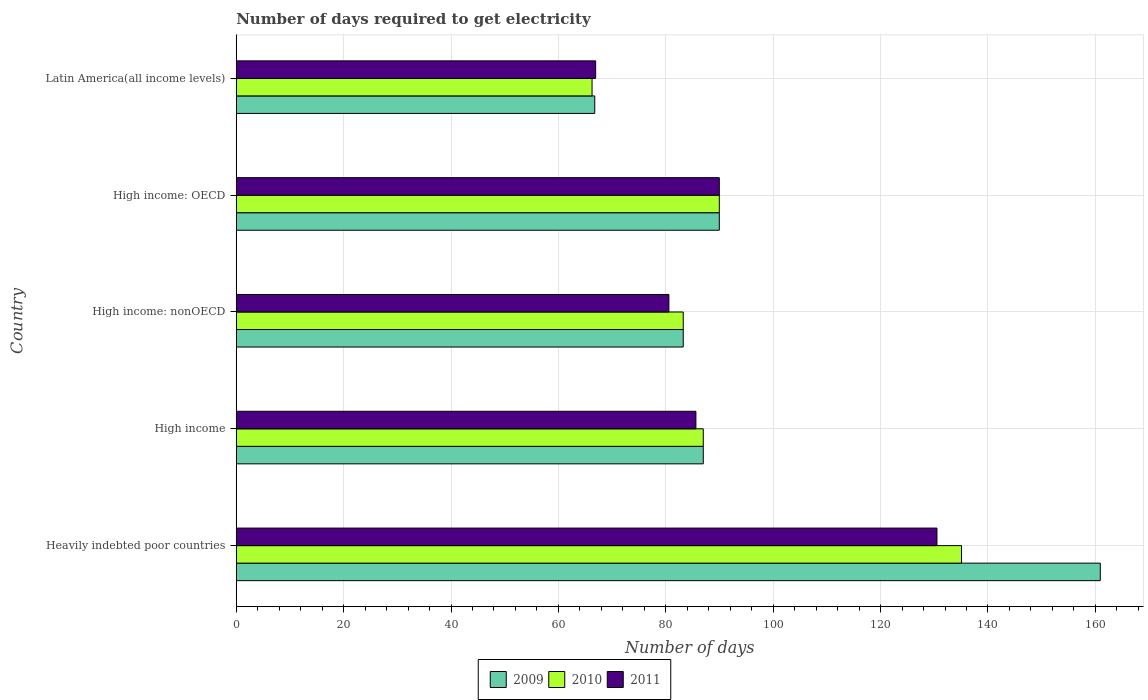How many groups of bars are there?
Your answer should be compact. 5. What is the label of the 5th group of bars from the top?
Your response must be concise. Heavily indebted poor countries. What is the number of days required to get electricity in in 2009 in High income?
Your answer should be very brief. 86.98. Across all countries, what is the maximum number of days required to get electricity in in 2009?
Ensure brevity in your answer.  160.92. Across all countries, what is the minimum number of days required to get electricity in in 2011?
Give a very brief answer. 66.94. In which country was the number of days required to get electricity in in 2011 maximum?
Keep it short and to the point. Heavily indebted poor countries. In which country was the number of days required to get electricity in in 2011 minimum?
Make the answer very short. Latin America(all income levels). What is the total number of days required to get electricity in in 2011 in the graph?
Your answer should be compact. 453.59. What is the difference between the number of days required to get electricity in in 2010 in High income: nonOECD and that in Latin America(all income levels)?
Keep it short and to the point. 16.98. What is the difference between the number of days required to get electricity in in 2009 in Latin America(all income levels) and the number of days required to get electricity in in 2011 in High income: nonOECD?
Give a very brief answer. -13.81. What is the average number of days required to get electricity in in 2011 per country?
Offer a terse response. 90.72. What is the difference between the number of days required to get electricity in in 2011 and number of days required to get electricity in in 2009 in High income: OECD?
Offer a terse response. 0. What is the ratio of the number of days required to get electricity in in 2010 in High income: nonOECD to that in Latin America(all income levels)?
Your answer should be compact. 1.26. Is the number of days required to get electricity in in 2010 in Heavily indebted poor countries less than that in High income: nonOECD?
Make the answer very short. No. Is the difference between the number of days required to get electricity in in 2011 in Heavily indebted poor countries and High income: nonOECD greater than the difference between the number of days required to get electricity in in 2009 in Heavily indebted poor countries and High income: nonOECD?
Your answer should be very brief. No. What is the difference between the highest and the second highest number of days required to get electricity in in 2009?
Offer a very short reply. 70.95. What is the difference between the highest and the lowest number of days required to get electricity in in 2010?
Offer a terse response. 68.81. What does the 1st bar from the bottom in High income: nonOECD represents?
Your response must be concise. 2009. How many bars are there?
Provide a short and direct response. 15. Are all the bars in the graph horizontal?
Your response must be concise. Yes. How many countries are there in the graph?
Your answer should be very brief. 5. What is the difference between two consecutive major ticks on the X-axis?
Keep it short and to the point. 20. Where does the legend appear in the graph?
Your answer should be very brief. Bottom center. What is the title of the graph?
Your response must be concise. Number of days required to get electricity. What is the label or title of the X-axis?
Ensure brevity in your answer.  Number of days. What is the label or title of the Y-axis?
Offer a terse response. Country. What is the Number of days in 2009 in Heavily indebted poor countries?
Give a very brief answer. 160.92. What is the Number of days of 2010 in Heavily indebted poor countries?
Offer a terse response. 135.08. What is the Number of days of 2011 in Heavily indebted poor countries?
Ensure brevity in your answer.  130.5. What is the Number of days of 2009 in High income?
Provide a succinct answer. 86.98. What is the Number of days in 2010 in High income?
Keep it short and to the point. 86.98. What is the Number of days in 2011 in High income?
Your response must be concise. 85.61. What is the Number of days in 2009 in High income: nonOECD?
Your answer should be compact. 83.25. What is the Number of days in 2010 in High income: nonOECD?
Your answer should be compact. 83.25. What is the Number of days in 2011 in High income: nonOECD?
Make the answer very short. 80.58. What is the Number of days in 2009 in High income: OECD?
Offer a very short reply. 89.97. What is the Number of days in 2010 in High income: OECD?
Offer a terse response. 89.97. What is the Number of days of 2011 in High income: OECD?
Provide a short and direct response. 89.97. What is the Number of days of 2009 in Latin America(all income levels)?
Provide a succinct answer. 66.77. What is the Number of days of 2010 in Latin America(all income levels)?
Your response must be concise. 66.27. What is the Number of days of 2011 in Latin America(all income levels)?
Offer a terse response. 66.94. Across all countries, what is the maximum Number of days of 2009?
Provide a short and direct response. 160.92. Across all countries, what is the maximum Number of days in 2010?
Your answer should be very brief. 135.08. Across all countries, what is the maximum Number of days of 2011?
Keep it short and to the point. 130.5. Across all countries, what is the minimum Number of days of 2009?
Provide a short and direct response. 66.77. Across all countries, what is the minimum Number of days of 2010?
Offer a very short reply. 66.27. Across all countries, what is the minimum Number of days of 2011?
Offer a very short reply. 66.94. What is the total Number of days of 2009 in the graph?
Provide a succinct answer. 487.89. What is the total Number of days of 2010 in the graph?
Offer a very short reply. 461.54. What is the total Number of days of 2011 in the graph?
Make the answer very short. 453.59. What is the difference between the Number of days in 2009 in Heavily indebted poor countries and that in High income?
Your answer should be compact. 73.94. What is the difference between the Number of days of 2010 in Heavily indebted poor countries and that in High income?
Your answer should be compact. 48.1. What is the difference between the Number of days in 2011 in Heavily indebted poor countries and that in High income?
Provide a succinct answer. 44.89. What is the difference between the Number of days in 2009 in Heavily indebted poor countries and that in High income: nonOECD?
Offer a very short reply. 77.67. What is the difference between the Number of days in 2010 in Heavily indebted poor countries and that in High income: nonOECD?
Your answer should be compact. 51.83. What is the difference between the Number of days of 2011 in Heavily indebted poor countries and that in High income: nonOECD?
Your response must be concise. 49.92. What is the difference between the Number of days in 2009 in Heavily indebted poor countries and that in High income: OECD?
Keep it short and to the point. 70.95. What is the difference between the Number of days of 2010 in Heavily indebted poor countries and that in High income: OECD?
Give a very brief answer. 45.11. What is the difference between the Number of days of 2011 in Heavily indebted poor countries and that in High income: OECD?
Your response must be concise. 40.53. What is the difference between the Number of days in 2009 in Heavily indebted poor countries and that in Latin America(all income levels)?
Your response must be concise. 94.15. What is the difference between the Number of days in 2010 in Heavily indebted poor countries and that in Latin America(all income levels)?
Offer a terse response. 68.81. What is the difference between the Number of days of 2011 in Heavily indebted poor countries and that in Latin America(all income levels)?
Offer a terse response. 63.56. What is the difference between the Number of days of 2009 in High income and that in High income: nonOECD?
Provide a succinct answer. 3.73. What is the difference between the Number of days in 2010 in High income and that in High income: nonOECD?
Offer a very short reply. 3.73. What is the difference between the Number of days of 2011 in High income and that in High income: nonOECD?
Your answer should be very brief. 5.03. What is the difference between the Number of days in 2009 in High income and that in High income: OECD?
Keep it short and to the point. -2.99. What is the difference between the Number of days of 2010 in High income and that in High income: OECD?
Make the answer very short. -2.99. What is the difference between the Number of days in 2011 in High income and that in High income: OECD?
Offer a very short reply. -4.36. What is the difference between the Number of days in 2009 in High income and that in Latin America(all income levels)?
Ensure brevity in your answer.  20.21. What is the difference between the Number of days of 2010 in High income and that in Latin America(all income levels)?
Give a very brief answer. 20.71. What is the difference between the Number of days of 2011 in High income and that in Latin America(all income levels)?
Provide a succinct answer. 18.67. What is the difference between the Number of days in 2009 in High income: nonOECD and that in High income: OECD?
Give a very brief answer. -6.72. What is the difference between the Number of days in 2010 in High income: nonOECD and that in High income: OECD?
Offer a very short reply. -6.72. What is the difference between the Number of days of 2011 in High income: nonOECD and that in High income: OECD?
Your answer should be compact. -9.39. What is the difference between the Number of days in 2009 in High income: nonOECD and that in Latin America(all income levels)?
Keep it short and to the point. 16.48. What is the difference between the Number of days in 2010 in High income: nonOECD and that in Latin America(all income levels)?
Your response must be concise. 16.98. What is the difference between the Number of days in 2011 in High income: nonOECD and that in Latin America(all income levels)?
Offer a terse response. 13.64. What is the difference between the Number of days in 2009 in High income: OECD and that in Latin America(all income levels)?
Keep it short and to the point. 23.2. What is the difference between the Number of days in 2010 in High income: OECD and that in Latin America(all income levels)?
Make the answer very short. 23.7. What is the difference between the Number of days of 2011 in High income: OECD and that in Latin America(all income levels)?
Provide a short and direct response. 23.03. What is the difference between the Number of days of 2009 in Heavily indebted poor countries and the Number of days of 2010 in High income?
Your answer should be very brief. 73.94. What is the difference between the Number of days of 2009 in Heavily indebted poor countries and the Number of days of 2011 in High income?
Provide a short and direct response. 75.31. What is the difference between the Number of days of 2010 in Heavily indebted poor countries and the Number of days of 2011 in High income?
Give a very brief answer. 49.47. What is the difference between the Number of days of 2009 in Heavily indebted poor countries and the Number of days of 2010 in High income: nonOECD?
Your answer should be very brief. 77.67. What is the difference between the Number of days of 2009 in Heavily indebted poor countries and the Number of days of 2011 in High income: nonOECD?
Offer a terse response. 80.34. What is the difference between the Number of days in 2010 in Heavily indebted poor countries and the Number of days in 2011 in High income: nonOECD?
Your response must be concise. 54.5. What is the difference between the Number of days in 2009 in Heavily indebted poor countries and the Number of days in 2010 in High income: OECD?
Give a very brief answer. 70.95. What is the difference between the Number of days in 2009 in Heavily indebted poor countries and the Number of days in 2011 in High income: OECD?
Your answer should be compact. 70.95. What is the difference between the Number of days in 2010 in Heavily indebted poor countries and the Number of days in 2011 in High income: OECD?
Ensure brevity in your answer.  45.11. What is the difference between the Number of days of 2009 in Heavily indebted poor countries and the Number of days of 2010 in Latin America(all income levels)?
Keep it short and to the point. 94.65. What is the difference between the Number of days in 2009 in Heavily indebted poor countries and the Number of days in 2011 in Latin America(all income levels)?
Your response must be concise. 93.99. What is the difference between the Number of days of 2010 in Heavily indebted poor countries and the Number of days of 2011 in Latin America(all income levels)?
Your answer should be compact. 68.14. What is the difference between the Number of days of 2009 in High income and the Number of days of 2010 in High income: nonOECD?
Keep it short and to the point. 3.73. What is the difference between the Number of days in 2009 in High income and the Number of days in 2011 in High income: nonOECD?
Keep it short and to the point. 6.4. What is the difference between the Number of days in 2010 in High income and the Number of days in 2011 in High income: nonOECD?
Provide a short and direct response. 6.4. What is the difference between the Number of days in 2009 in High income and the Number of days in 2010 in High income: OECD?
Offer a very short reply. -2.99. What is the difference between the Number of days of 2009 in High income and the Number of days of 2011 in High income: OECD?
Keep it short and to the point. -2.99. What is the difference between the Number of days of 2010 in High income and the Number of days of 2011 in High income: OECD?
Your response must be concise. -2.99. What is the difference between the Number of days of 2009 in High income and the Number of days of 2010 in Latin America(all income levels)?
Offer a terse response. 20.71. What is the difference between the Number of days in 2009 in High income and the Number of days in 2011 in Latin America(all income levels)?
Give a very brief answer. 20.05. What is the difference between the Number of days in 2010 in High income and the Number of days in 2011 in Latin America(all income levels)?
Ensure brevity in your answer.  20.05. What is the difference between the Number of days in 2009 in High income: nonOECD and the Number of days in 2010 in High income: OECD?
Provide a succinct answer. -6.72. What is the difference between the Number of days in 2009 in High income: nonOECD and the Number of days in 2011 in High income: OECD?
Give a very brief answer. -6.72. What is the difference between the Number of days of 2010 in High income: nonOECD and the Number of days of 2011 in High income: OECD?
Your answer should be very brief. -6.72. What is the difference between the Number of days in 2009 in High income: nonOECD and the Number of days in 2010 in Latin America(all income levels)?
Your response must be concise. 16.98. What is the difference between the Number of days of 2009 in High income: nonOECD and the Number of days of 2011 in Latin America(all income levels)?
Ensure brevity in your answer.  16.31. What is the difference between the Number of days of 2010 in High income: nonOECD and the Number of days of 2011 in Latin America(all income levels)?
Give a very brief answer. 16.31. What is the difference between the Number of days of 2009 in High income: OECD and the Number of days of 2010 in Latin America(all income levels)?
Keep it short and to the point. 23.7. What is the difference between the Number of days in 2009 in High income: OECD and the Number of days in 2011 in Latin America(all income levels)?
Offer a terse response. 23.03. What is the difference between the Number of days of 2010 in High income: OECD and the Number of days of 2011 in Latin America(all income levels)?
Your answer should be very brief. 23.03. What is the average Number of days of 2009 per country?
Give a very brief answer. 97.58. What is the average Number of days of 2010 per country?
Your answer should be very brief. 92.31. What is the average Number of days in 2011 per country?
Keep it short and to the point. 90.72. What is the difference between the Number of days in 2009 and Number of days in 2010 in Heavily indebted poor countries?
Keep it short and to the point. 25.84. What is the difference between the Number of days of 2009 and Number of days of 2011 in Heavily indebted poor countries?
Provide a succinct answer. 30.42. What is the difference between the Number of days of 2010 and Number of days of 2011 in Heavily indebted poor countries?
Offer a very short reply. 4.58. What is the difference between the Number of days of 2009 and Number of days of 2010 in High income?
Provide a short and direct response. 0. What is the difference between the Number of days in 2009 and Number of days in 2011 in High income?
Your answer should be compact. 1.37. What is the difference between the Number of days of 2010 and Number of days of 2011 in High income?
Your answer should be compact. 1.37. What is the difference between the Number of days in 2009 and Number of days in 2010 in High income: nonOECD?
Offer a terse response. 0. What is the difference between the Number of days in 2009 and Number of days in 2011 in High income: nonOECD?
Keep it short and to the point. 2.67. What is the difference between the Number of days in 2010 and Number of days in 2011 in High income: nonOECD?
Make the answer very short. 2.67. What is the difference between the Number of days of 2009 and Number of days of 2010 in High income: OECD?
Your answer should be very brief. 0. What is the difference between the Number of days in 2009 and Number of days in 2011 in High income: OECD?
Your answer should be very brief. 0. What is the difference between the Number of days in 2010 and Number of days in 2011 in High income: OECD?
Provide a short and direct response. 0. What is the difference between the Number of days in 2009 and Number of days in 2010 in Latin America(all income levels)?
Give a very brief answer. 0.5. What is the difference between the Number of days of 2009 and Number of days of 2011 in Latin America(all income levels)?
Give a very brief answer. -0.17. What is the difference between the Number of days in 2010 and Number of days in 2011 in Latin America(all income levels)?
Make the answer very short. -0.67. What is the ratio of the Number of days of 2009 in Heavily indebted poor countries to that in High income?
Your response must be concise. 1.85. What is the ratio of the Number of days of 2010 in Heavily indebted poor countries to that in High income?
Offer a terse response. 1.55. What is the ratio of the Number of days in 2011 in Heavily indebted poor countries to that in High income?
Offer a terse response. 1.52. What is the ratio of the Number of days in 2009 in Heavily indebted poor countries to that in High income: nonOECD?
Provide a short and direct response. 1.93. What is the ratio of the Number of days in 2010 in Heavily indebted poor countries to that in High income: nonOECD?
Ensure brevity in your answer.  1.62. What is the ratio of the Number of days of 2011 in Heavily indebted poor countries to that in High income: nonOECD?
Your response must be concise. 1.62. What is the ratio of the Number of days in 2009 in Heavily indebted poor countries to that in High income: OECD?
Ensure brevity in your answer.  1.79. What is the ratio of the Number of days of 2010 in Heavily indebted poor countries to that in High income: OECD?
Your response must be concise. 1.5. What is the ratio of the Number of days of 2011 in Heavily indebted poor countries to that in High income: OECD?
Provide a succinct answer. 1.45. What is the ratio of the Number of days in 2009 in Heavily indebted poor countries to that in Latin America(all income levels)?
Provide a short and direct response. 2.41. What is the ratio of the Number of days of 2010 in Heavily indebted poor countries to that in Latin America(all income levels)?
Keep it short and to the point. 2.04. What is the ratio of the Number of days in 2011 in Heavily indebted poor countries to that in Latin America(all income levels)?
Keep it short and to the point. 1.95. What is the ratio of the Number of days of 2009 in High income to that in High income: nonOECD?
Offer a terse response. 1.04. What is the ratio of the Number of days in 2010 in High income to that in High income: nonOECD?
Offer a very short reply. 1.04. What is the ratio of the Number of days of 2011 in High income to that in High income: nonOECD?
Provide a succinct answer. 1.06. What is the ratio of the Number of days in 2009 in High income to that in High income: OECD?
Offer a terse response. 0.97. What is the ratio of the Number of days of 2010 in High income to that in High income: OECD?
Provide a succinct answer. 0.97. What is the ratio of the Number of days in 2011 in High income to that in High income: OECD?
Your answer should be compact. 0.95. What is the ratio of the Number of days of 2009 in High income to that in Latin America(all income levels)?
Provide a short and direct response. 1.3. What is the ratio of the Number of days in 2010 in High income to that in Latin America(all income levels)?
Provide a short and direct response. 1.31. What is the ratio of the Number of days of 2011 in High income to that in Latin America(all income levels)?
Give a very brief answer. 1.28. What is the ratio of the Number of days in 2009 in High income: nonOECD to that in High income: OECD?
Keep it short and to the point. 0.93. What is the ratio of the Number of days in 2010 in High income: nonOECD to that in High income: OECD?
Your response must be concise. 0.93. What is the ratio of the Number of days of 2011 in High income: nonOECD to that in High income: OECD?
Make the answer very short. 0.9. What is the ratio of the Number of days in 2009 in High income: nonOECD to that in Latin America(all income levels)?
Provide a succinct answer. 1.25. What is the ratio of the Number of days of 2010 in High income: nonOECD to that in Latin America(all income levels)?
Offer a terse response. 1.26. What is the ratio of the Number of days in 2011 in High income: nonOECD to that in Latin America(all income levels)?
Give a very brief answer. 1.2. What is the ratio of the Number of days in 2009 in High income: OECD to that in Latin America(all income levels)?
Provide a succinct answer. 1.35. What is the ratio of the Number of days in 2010 in High income: OECD to that in Latin America(all income levels)?
Provide a succinct answer. 1.36. What is the ratio of the Number of days in 2011 in High income: OECD to that in Latin America(all income levels)?
Your response must be concise. 1.34. What is the difference between the highest and the second highest Number of days in 2009?
Give a very brief answer. 70.95. What is the difference between the highest and the second highest Number of days of 2010?
Ensure brevity in your answer.  45.11. What is the difference between the highest and the second highest Number of days in 2011?
Provide a succinct answer. 40.53. What is the difference between the highest and the lowest Number of days in 2009?
Ensure brevity in your answer.  94.15. What is the difference between the highest and the lowest Number of days in 2010?
Provide a succinct answer. 68.81. What is the difference between the highest and the lowest Number of days of 2011?
Provide a short and direct response. 63.56. 